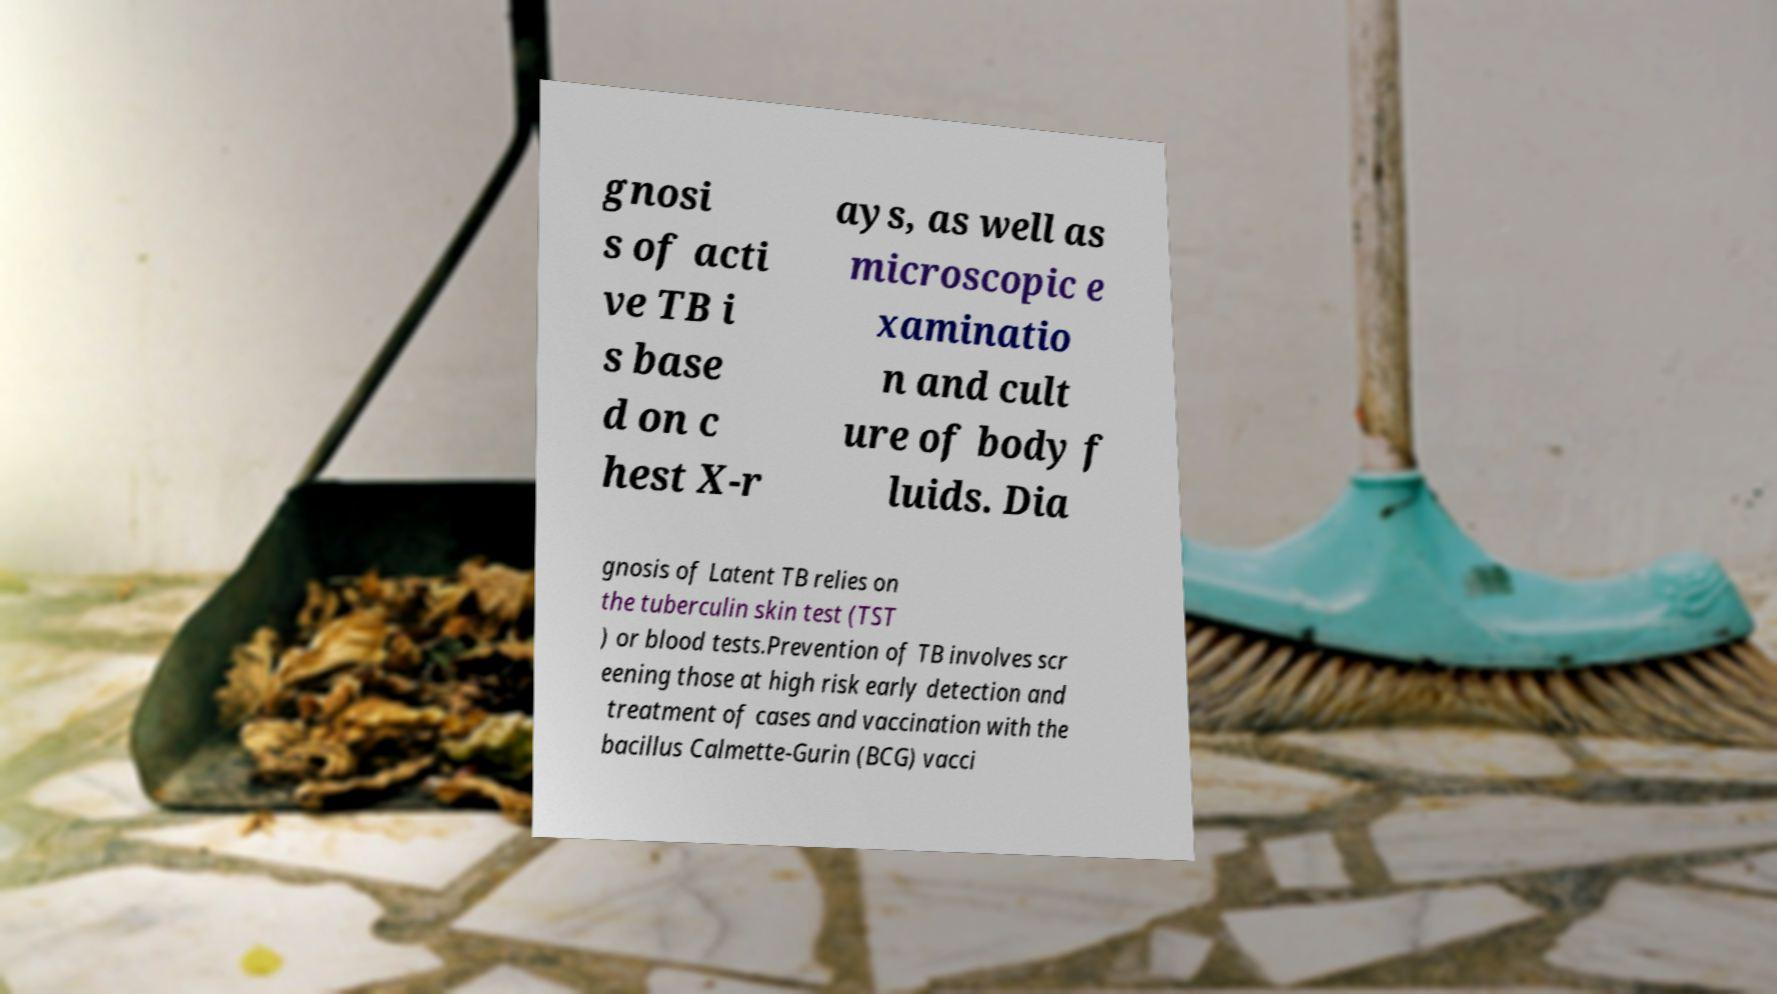There's text embedded in this image that I need extracted. Can you transcribe it verbatim? gnosi s of acti ve TB i s base d on c hest X-r ays, as well as microscopic e xaminatio n and cult ure of body f luids. Dia gnosis of Latent TB relies on the tuberculin skin test (TST ) or blood tests.Prevention of TB involves scr eening those at high risk early detection and treatment of cases and vaccination with the bacillus Calmette-Gurin (BCG) vacci 